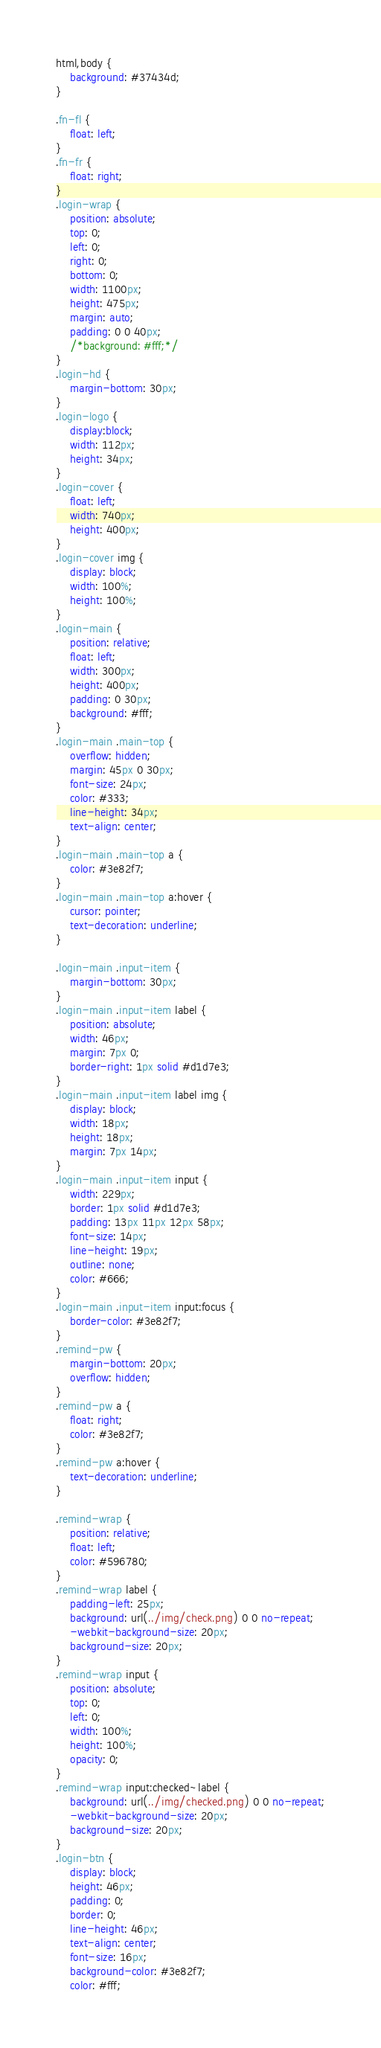Convert code to text. <code><loc_0><loc_0><loc_500><loc_500><_CSS_>html,body {
    background: #37434d;
}

.fn-fl {
    float: left;
}
.fn-fr {
    float: right;
}
.login-wrap {
    position: absolute;
    top: 0;
    left: 0;
    right: 0;
    bottom: 0;
    width: 1100px;
    height: 475px;
    margin: auto;
    padding: 0 0 40px;
    /*background: #fff;*/
}
.login-hd {
    margin-bottom: 30px;
}
.login-logo {
    display:block;
    width: 112px;
    height: 34px;
}
.login-cover {
    float: left;
    width: 740px;
    height: 400px;
}
.login-cover img {
    display: block;
    width: 100%;
    height: 100%;
}
.login-main {
    position: relative;
    float: left;
    width: 300px;
    height: 400px;
    padding: 0 30px;
    background: #fff;
}
.login-main .main-top {
    overflow: hidden;
    margin: 45px 0 30px;
    font-size: 24px;
    color: #333;
    line-height: 34px;
    text-align: center;
}
.login-main .main-top a {
    color: #3e82f7;
}
.login-main .main-top a:hover {
    cursor: pointer;
    text-decoration: underline;
}

.login-main .input-item {
    margin-bottom: 30px;
}
.login-main .input-item label {
    position: absolute;
    width: 46px;
    margin: 7px 0;
    border-right: 1px solid #d1d7e3;
}
.login-main .input-item label img {
    display: block;
    width: 18px;
    height: 18px;
    margin: 7px 14px;
}
.login-main .input-item input {
    width: 229px;
    border: 1px solid #d1d7e3;
    padding: 13px 11px 12px 58px;
    font-size: 14px;
    line-height: 19px;
    outline: none;
    color: #666;
}
.login-main .input-item input:focus {
    border-color: #3e82f7;
}
.remind-pw {
    margin-bottom: 20px;
    overflow: hidden;
}
.remind-pw a {
    float: right;
    color: #3e82f7;
}
.remind-pw a:hover {
    text-decoration: underline;
}

.remind-wrap {
    position: relative;
    float: left;
    color: #596780;
}
.remind-wrap label {
    padding-left: 25px;
    background: url(../img/check.png) 0 0 no-repeat;
    -webkit-background-size: 20px;
    background-size: 20px;
}
.remind-wrap input {
    position: absolute;
    top: 0;
    left: 0;
    width: 100%;
    height: 100%;
    opacity: 0;
}
.remind-wrap input:checked~label {
    background: url(../img/checked.png) 0 0 no-repeat;
    -webkit-background-size: 20px;
    background-size: 20px;
}
.login-btn {
    display: block;
    height: 46px;
    padding: 0;
    border: 0;
    line-height: 46px;
    text-align: center;
    font-size: 16px;
    background-color: #3e82f7;
    color: #fff;</code> 